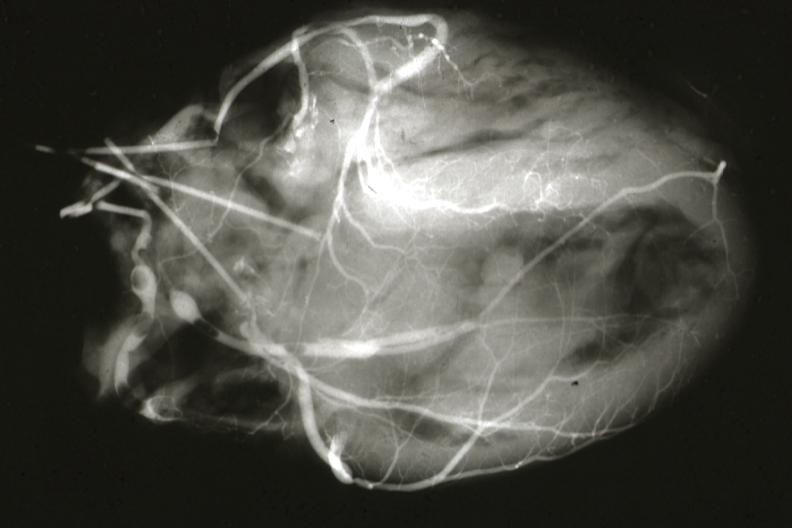what is present?
Answer the question using a single word or phrase. Cardiovascular 